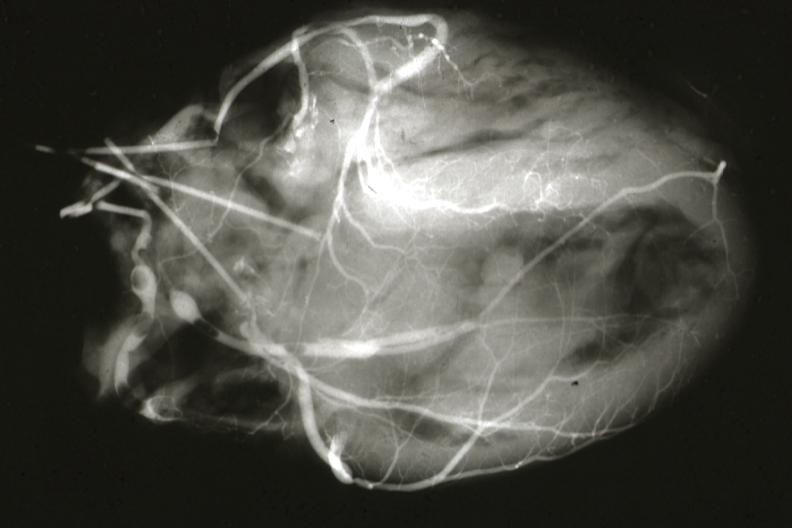what is present?
Answer the question using a single word or phrase. Cardiovascular 